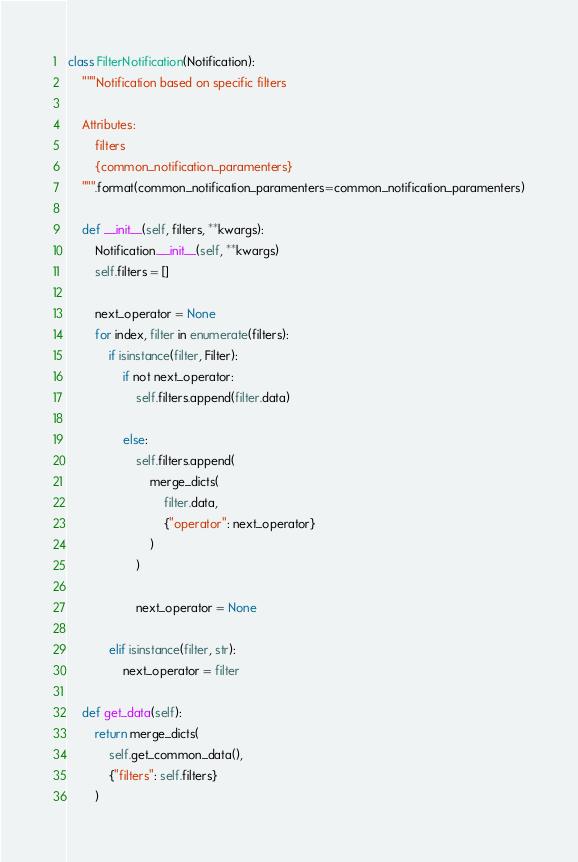Convert code to text. <code><loc_0><loc_0><loc_500><loc_500><_Python_>class FilterNotification(Notification):
    """Notification based on specific filters

    Attributes:
        filters
        {common_notification_paramenters}
    """.format(common_notification_paramenters=common_notification_paramenters)

    def __init__(self, filters, **kwargs):
        Notification.__init__(self, **kwargs)
        self.filters = []

        next_operator = None
        for index, filter in enumerate(filters):
            if isinstance(filter, Filter):
                if not next_operator:
                    self.filters.append(filter.data)

                else:
                    self.filters.append(
                        merge_dicts(
                            filter.data,
                            {"operator": next_operator}
                        )
                    )

                    next_operator = None

            elif isinstance(filter, str):
                next_operator = filter

    def get_data(self):
        return merge_dicts(
            self.get_common_data(),
            {"filters": self.filters}
        )
</code> 